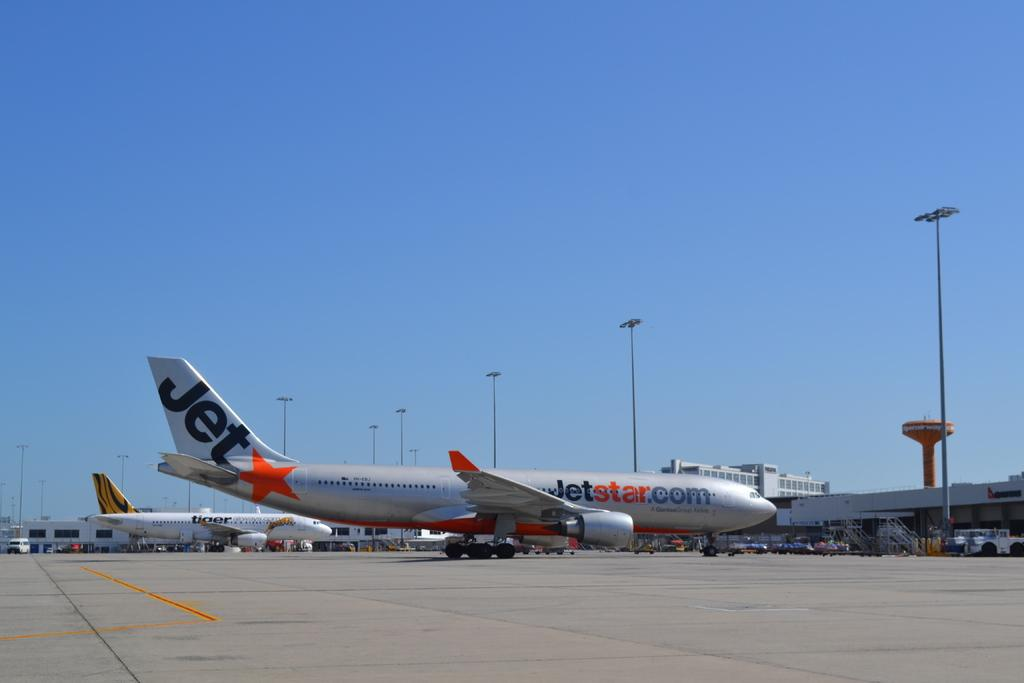<image>
Provide a brief description of the given image. An airplane with the word jet written on the tail 